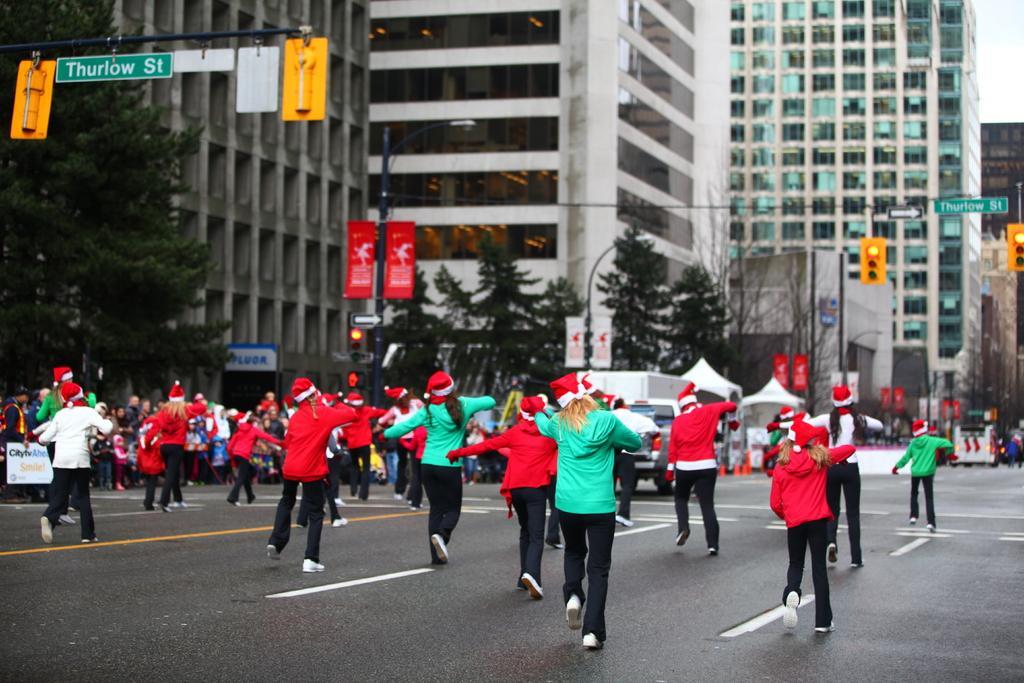Can you describe this image briefly? In this image, I can see a group of people with christmas hats are dancing on the road and few people standing. At the top left side of the image, there are boards attached to a pole. In front of these people, I can see the buildings, trees, poles and a vehicle. 